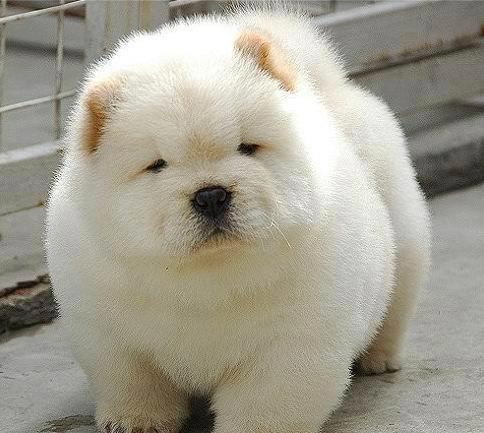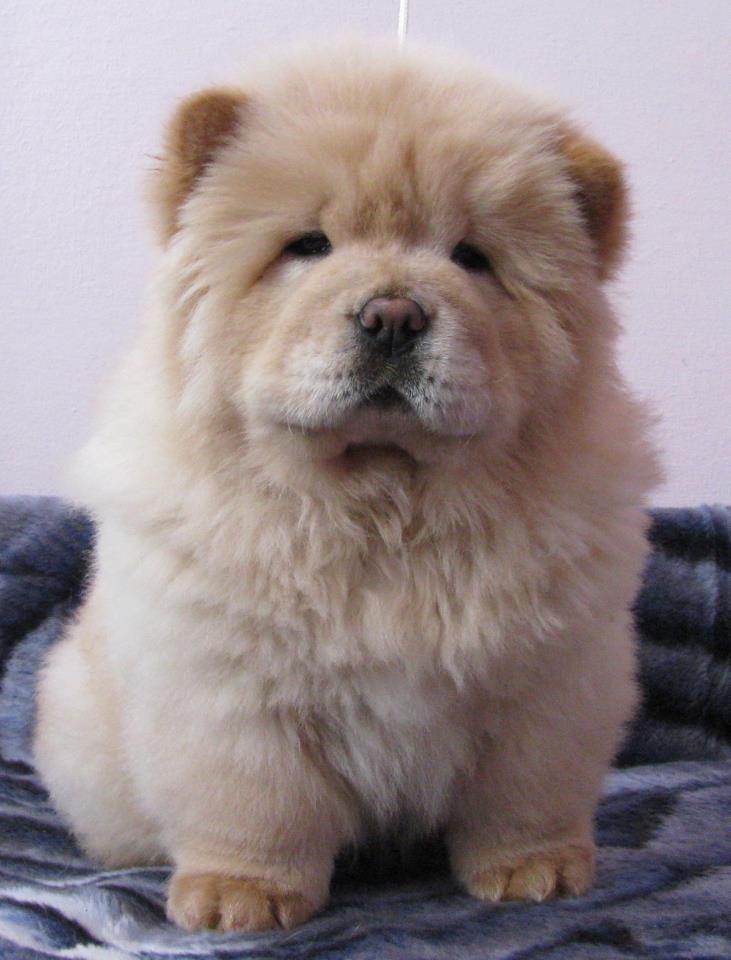The first image is the image on the left, the second image is the image on the right. For the images shown, is this caption "THere are exactly two dogs in the image on the left." true? Answer yes or no. No. The first image is the image on the left, the second image is the image on the right. Considering the images on both sides, is "An image shows two chow puppies side by side between stone walls." valid? Answer yes or no. No. 